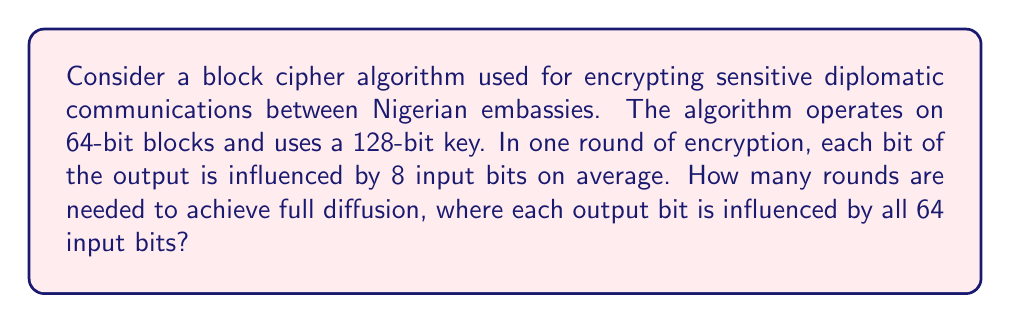Solve this math problem. To solve this problem, we need to understand the concept of diffusion in cryptography and apply it to the given scenario. Let's break it down step by step:

1. Diffusion property: This ensures that changing one bit of the plaintext should change many bits in the ciphertext. Full diffusion is achieved when each output bit is influenced by all input bits.

2. Given information:
   - Block size: 64 bits
   - In one round, each output bit is influenced by 8 input bits on average

3. Let's calculate how many bits are influenced after each round:
   - Round 1: 8 bits
   - Round 2: $8 \times 8 = 64$ bits

4. We can express this mathematically as:
   $$ \text{Bits influenced} = 8^n $$
   where $n$ is the number of rounds.

5. We need to find $n$ such that $8^n \geq 64$ (the block size)

6. Taking logarithms on both sides:
   $$ n \log_2(8) \geq \log_2(64) $$
   $$ 3n \geq 6 $$
   $$ n \geq 2 $$

7. Since $n$ must be an integer, the minimum number of rounds needed is 2.

This result shows that after 2 rounds, each output bit is potentially influenced by all 64 input bits, achieving full diffusion.
Answer: 2 rounds 